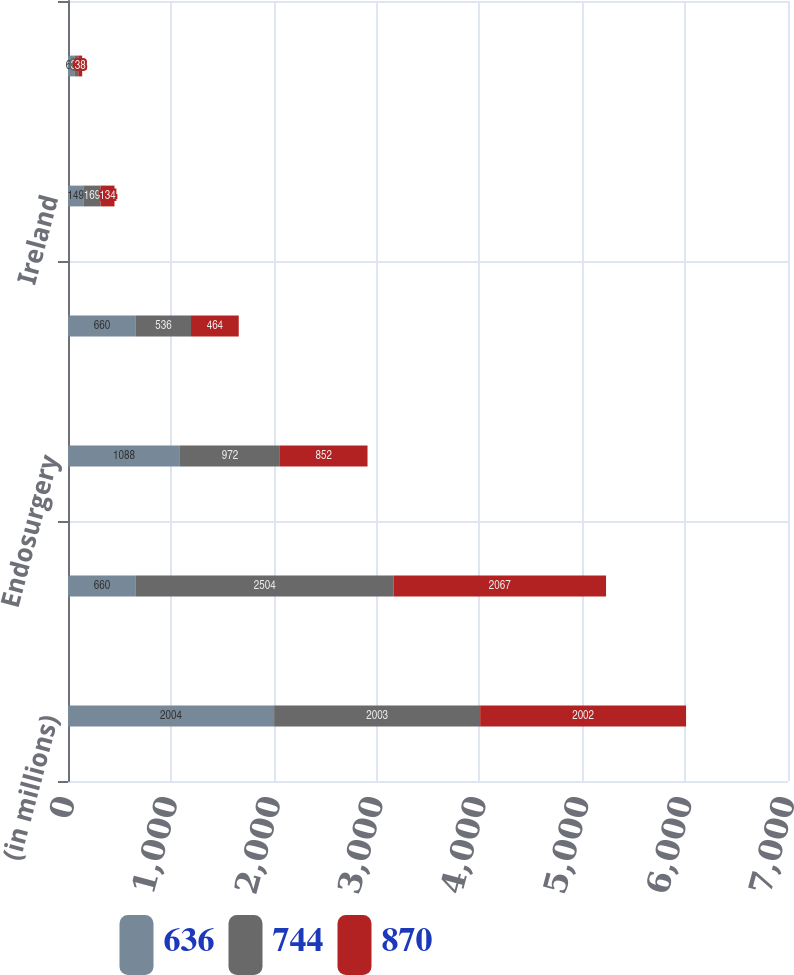<chart> <loc_0><loc_0><loc_500><loc_500><stacked_bar_chart><ecel><fcel>(in millions)<fcel>Cardiovascular<fcel>Endosurgery<fcel>United States<fcel>Ireland<fcel>Other foreign countries<nl><fcel>636<fcel>2004<fcel>660<fcel>1088<fcel>660<fcel>149<fcel>61<nl><fcel>744<fcel>2003<fcel>2504<fcel>972<fcel>536<fcel>169<fcel>39<nl><fcel>870<fcel>2002<fcel>2067<fcel>852<fcel>464<fcel>134<fcel>38<nl></chart> 